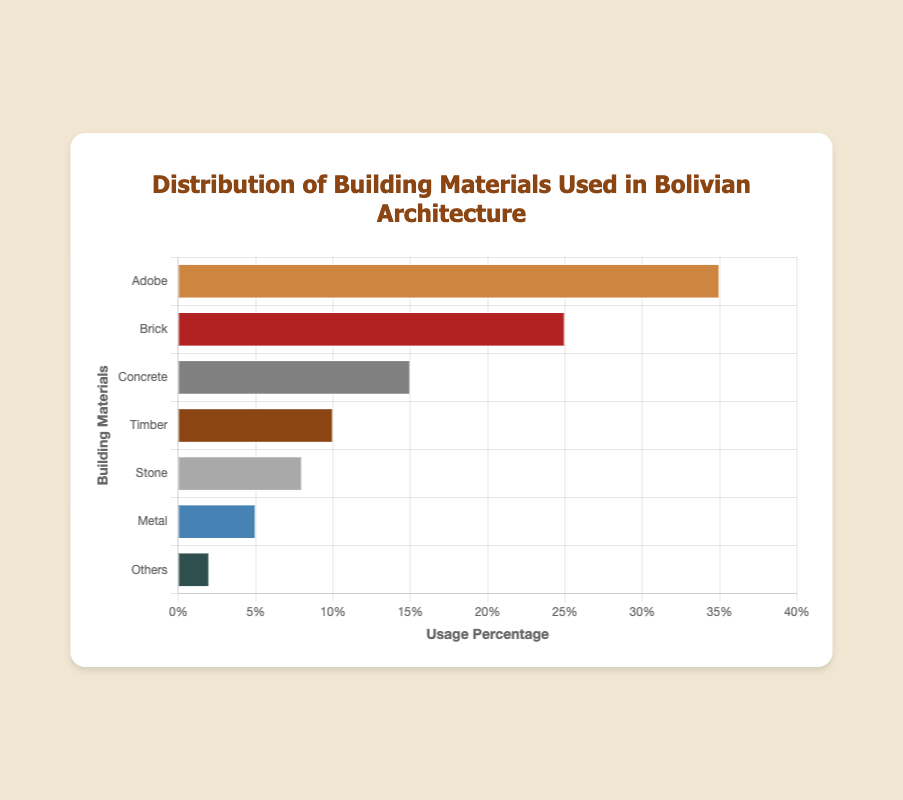What material is used the most for building in Bolivian architecture? The material with the highest usage percentage is identified by the tallest bar in the chart. Adobe has the tallest bar.
Answer: Adobe Which material is used more, Concrete or Timber? Compare the heights of the bars for Concrete and Timber. The Concrete bar is taller with a 15% usage, whereas the Timber bar is shorter with 10%.
Answer: Concrete How much more is Adobe used compared to Brick? Subtract the usage percentage of Brick from Adobe. Adobe is used 35% and Brick is used 25%, so the difference is 35% - 25%.
Answer: 10% What is the total usage percentage of Concrete, Stone, and Metal? Add the usage percentages of Concrete (15%), Stone (8%), and Metal (5%). 15% + 8% + 5% = 28%.
Answer: 28% Which materials have usage percentages less than 10%? Identify the bars that are shorter than the 10% mark. Timber (10%), Stone (8%), Metal (5%), and Others (2%) have percentages below 10%.
Answer: Stone, Metal, Others How does the usage of Brick compare to the combined usage of Stone and Metal? Add the usage percentages of Stone and Metal, and then compare it to Brick. Stone and Metal together make 8% + 5% = 13%, while Brick alone is 25%.
Answer: Brick is used more What is the average usage percentage of all materials listed? Add the usage percentages of all materials and divide by the number of materials. (35% + 25% + 15% + 10% + 8% + 5% + 2%) / 7 = 100% / 7 ≈ 14.29%.
Answer: ~14.29% How much less is the usage of Others compared to Timber? Subtract the usage percentage of Others from Timber. Timber is used 10%, Others 2%, so the difference is 10% - 2%.
Answer: 8% Which material has the lowest usage percentage and what is it? Identify the shortest bar in the chart. The Others bar is the shortest with a 2% usage percentage.
Answer: Others with 2% What is the combined usage percentage of the top two materials? Add the usage percentages of the top two materials: Adobe (35%) and Brick (25%). 35% + 25% = 60%.
Answer: 60% 